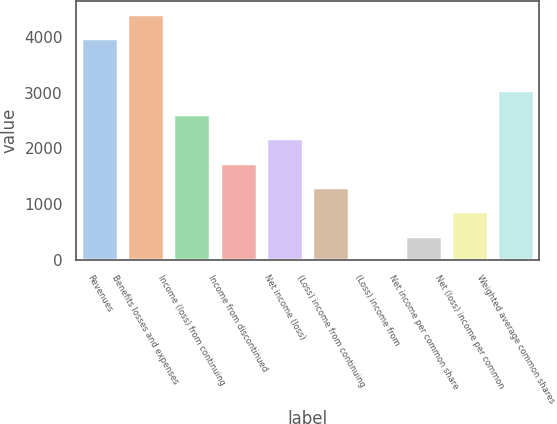<chart> <loc_0><loc_0><loc_500><loc_500><bar_chart><fcel>Revenues<fcel>Benefits losses and expenses<fcel>Income (loss) from continuing<fcel>Income from discontinued<fcel>Net income (loss)<fcel>(Loss) income from continuing<fcel>(Loss) income from<fcel>Net income per common share<fcel>Net (loss) income per common<fcel>Weighted average common shares<nl><fcel>3978<fcel>4413.39<fcel>2612.48<fcel>1741.7<fcel>2177.09<fcel>1306.31<fcel>0.14<fcel>435.53<fcel>870.92<fcel>3047.87<nl></chart> 